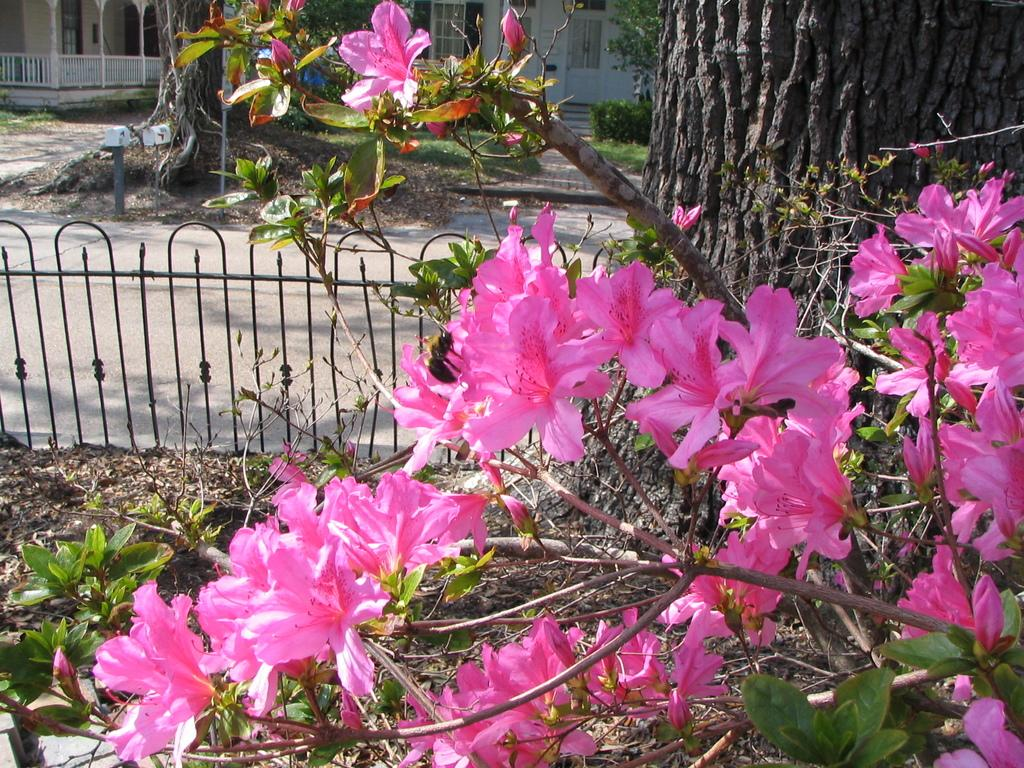What types of vegetation can be seen at the bottom of the image? There are flowers and trees at the bottom of the image. What is located behind the trees at the bottom of the image? There is fencing behind the trees. What types of vegetation can be seen at the top of the image? There are trees and plants at the top of the image. What type of structure is present at the top of the image? There is a building at the top of the image. What color is the brick used to build the uncle's house in the image? There is no uncle or house present in the image, and therefore no brick can be observed. 